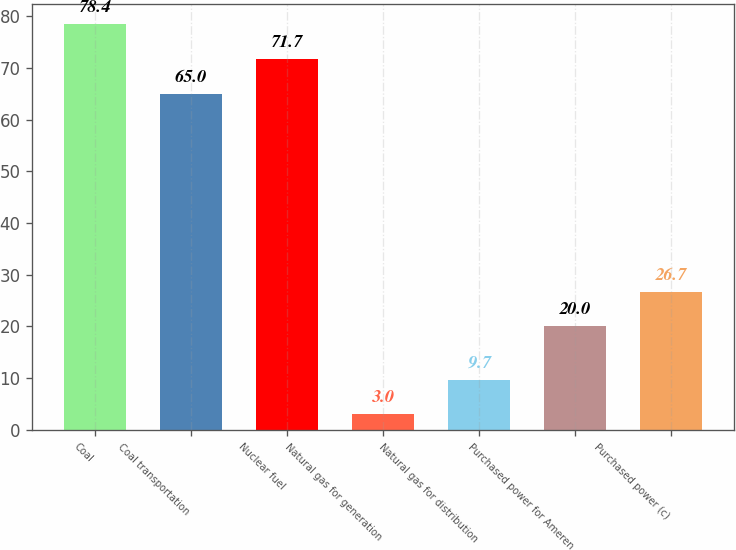<chart> <loc_0><loc_0><loc_500><loc_500><bar_chart><fcel>Coal<fcel>Coal transportation<fcel>Nuclear fuel<fcel>Natural gas for generation<fcel>Natural gas for distribution<fcel>Purchased power for Ameren<fcel>Purchased power (c)<nl><fcel>78.4<fcel>65<fcel>71.7<fcel>3<fcel>9.7<fcel>20<fcel>26.7<nl></chart> 